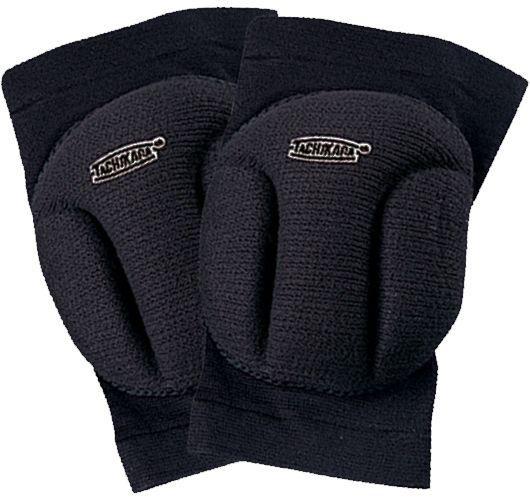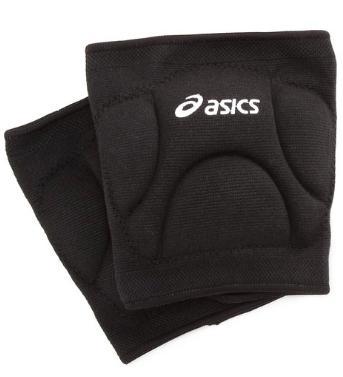The first image is the image on the left, the second image is the image on the right. Analyze the images presented: Is the assertion "Each image contains one pair of black knee pads, but only one image features a pair of knee pads with logos visible on each pad." valid? Answer yes or no. Yes. The first image is the image on the left, the second image is the image on the right. Examine the images to the left and right. Is the description "There are two pairs of knee pads laying flat." accurate? Answer yes or no. Yes. 